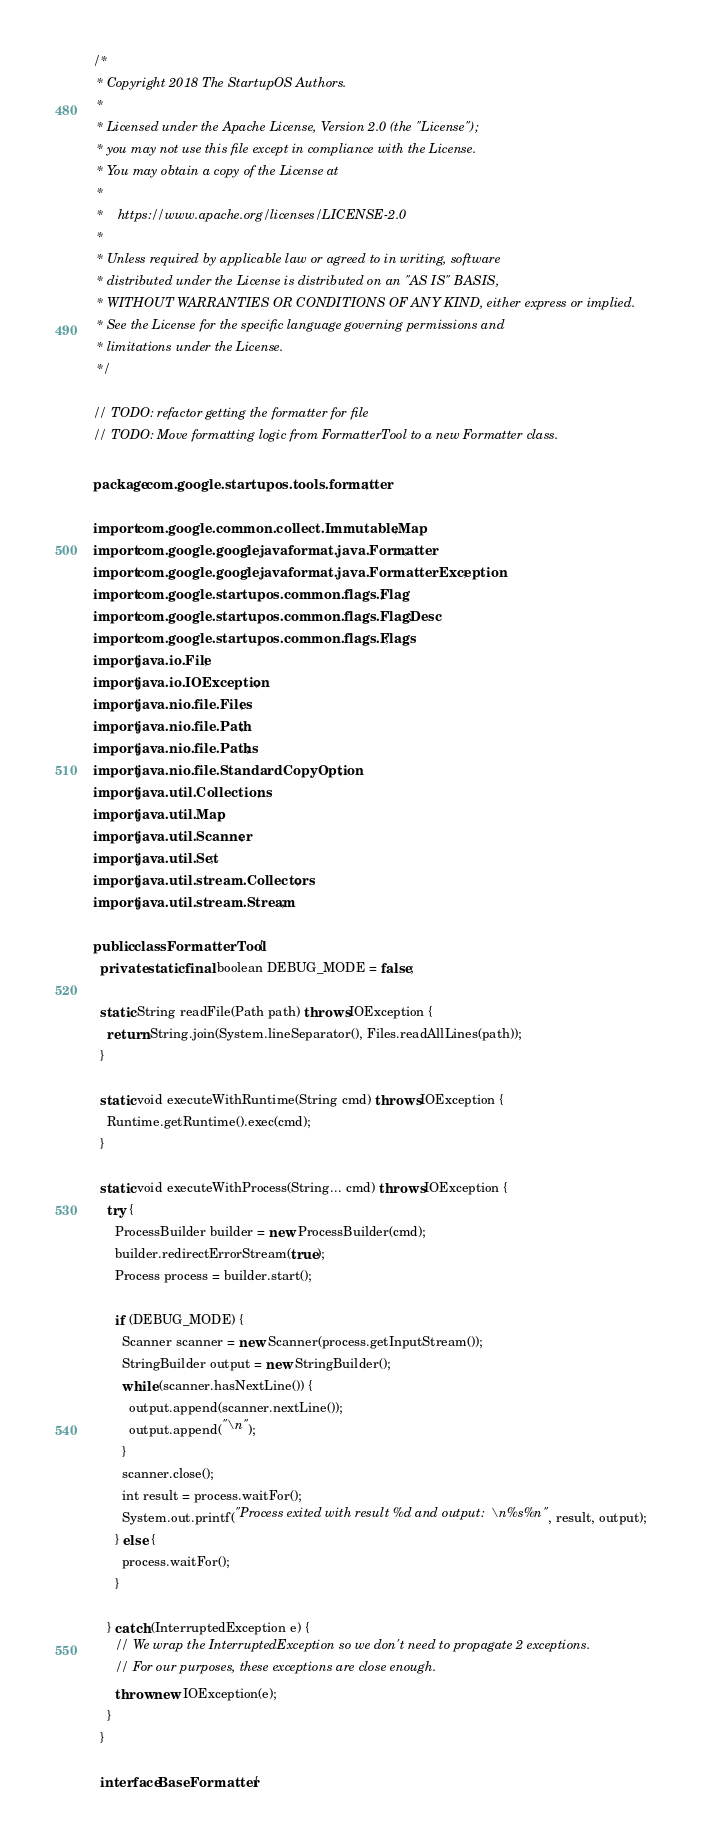Convert code to text. <code><loc_0><loc_0><loc_500><loc_500><_Java_>/*
 * Copyright 2018 The StartupOS Authors.
 *
 * Licensed under the Apache License, Version 2.0 (the "License");
 * you may not use this file except in compliance with the License.
 * You may obtain a copy of the License at
 *
 *    https://www.apache.org/licenses/LICENSE-2.0
 *
 * Unless required by applicable law or agreed to in writing, software
 * distributed under the License is distributed on an "AS IS" BASIS,
 * WITHOUT WARRANTIES OR CONDITIONS OF ANY KIND, either express or implied.
 * See the License for the specific language governing permissions and
 * limitations under the License.
 */

// TODO: refactor getting the formatter for file
// TODO: Move formatting logic from FormatterTool to a new Formatter class.

package com.google.startupos.tools.formatter;

import com.google.common.collect.ImmutableMap;
import com.google.googlejavaformat.java.Formatter;
import com.google.googlejavaformat.java.FormatterException;
import com.google.startupos.common.flags.Flag;
import com.google.startupos.common.flags.FlagDesc;
import com.google.startupos.common.flags.Flags;
import java.io.File;
import java.io.IOException;
import java.nio.file.Files;
import java.nio.file.Path;
import java.nio.file.Paths;
import java.nio.file.StandardCopyOption;
import java.util.Collections;
import java.util.Map;
import java.util.Scanner;
import java.util.Set;
import java.util.stream.Collectors;
import java.util.stream.Stream;

public class FormatterTool {
  private static final boolean DEBUG_MODE = false;

  static String readFile(Path path) throws IOException {
    return String.join(System.lineSeparator(), Files.readAllLines(path));
  }

  static void executeWithRuntime(String cmd) throws IOException {
    Runtime.getRuntime().exec(cmd);
  }

  static void executeWithProcess(String... cmd) throws IOException {
    try {
      ProcessBuilder builder = new ProcessBuilder(cmd);
      builder.redirectErrorStream(true);
      Process process = builder.start();

      if (DEBUG_MODE) {
        Scanner scanner = new Scanner(process.getInputStream());
        StringBuilder output = new StringBuilder();
        while (scanner.hasNextLine()) {
          output.append(scanner.nextLine());
          output.append("\n");
        }
        scanner.close();
        int result = process.waitFor();
        System.out.printf("Process exited with result %d and output:\n%s%n", result, output);
      } else {
        process.waitFor();
      }

    } catch (InterruptedException e) {
      // We wrap the InterruptedException so we don't need to propagate 2 exceptions.
      // For our purposes, these exceptions are close enough.
      throw new IOException(e);
    }
  }

  interface BaseFormatter {</code> 